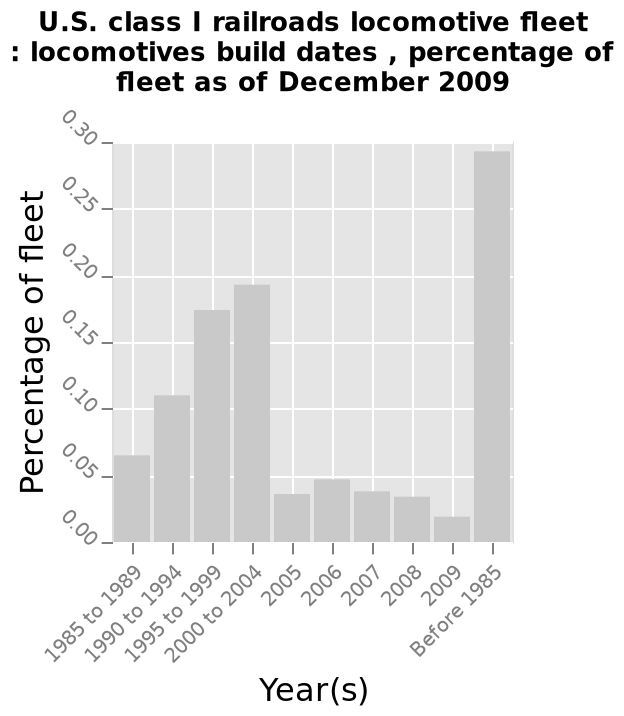<image>
What was the percentage of fleet in 2005?  The percentage of fleet in 2005 is unknown as it is not mentioned in the description. What does the x-axis represent on the bar chart? The x-axis represents the build dates of the locomotives. What is the timeframe covered by the data on the bar chart? The data is as of December 2009. 